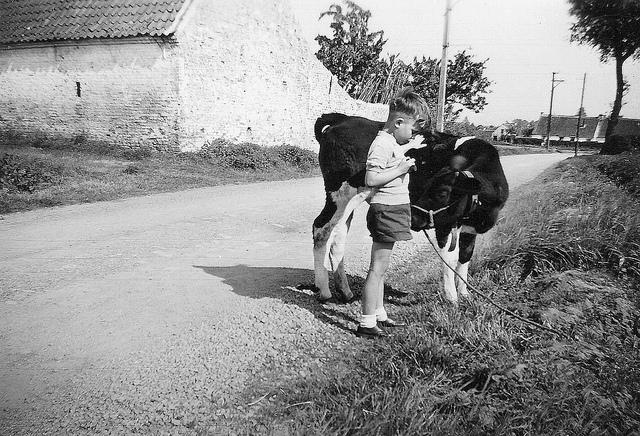Is the cow wearing anything?
Short answer required. Yes. Does the photo have color?
Short answer required. No. Are the boy and cow friends?
Answer briefly. Yes. How is the man leading the horse?
Keep it brief. Rope. Is this person walking on dry ground?
Write a very short answer. Yes. 